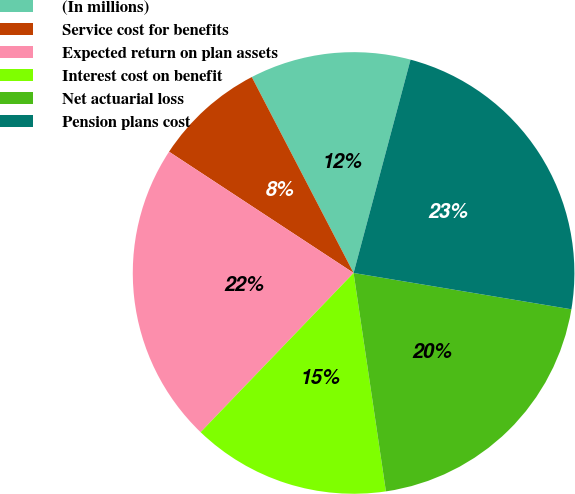<chart> <loc_0><loc_0><loc_500><loc_500><pie_chart><fcel>(In millions)<fcel>Service cost for benefits<fcel>Expected return on plan assets<fcel>Interest cost on benefit<fcel>Net actuarial loss<fcel>Pension plans cost<nl><fcel>11.78%<fcel>8.12%<fcel>22.07%<fcel>14.52%<fcel>20.03%<fcel>23.48%<nl></chart> 